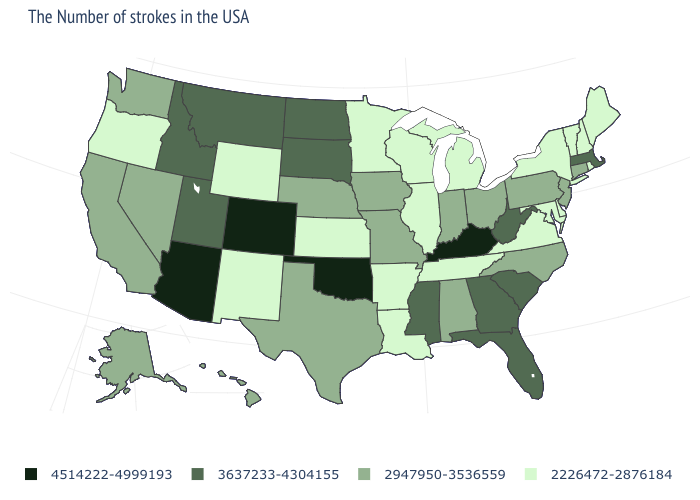What is the value of South Dakota?
Be succinct. 3637233-4304155. What is the value of Nevada?
Answer briefly. 2947950-3536559. Name the states that have a value in the range 2226472-2876184?
Be succinct. Maine, Rhode Island, New Hampshire, Vermont, New York, Delaware, Maryland, Virginia, Michigan, Tennessee, Wisconsin, Illinois, Louisiana, Arkansas, Minnesota, Kansas, Wyoming, New Mexico, Oregon. Is the legend a continuous bar?
Quick response, please. No. What is the value of Missouri?
Give a very brief answer. 2947950-3536559. What is the value of Rhode Island?
Give a very brief answer. 2226472-2876184. Does Oklahoma have the highest value in the USA?
Write a very short answer. Yes. Which states have the lowest value in the USA?
Keep it brief. Maine, Rhode Island, New Hampshire, Vermont, New York, Delaware, Maryland, Virginia, Michigan, Tennessee, Wisconsin, Illinois, Louisiana, Arkansas, Minnesota, Kansas, Wyoming, New Mexico, Oregon. Which states have the lowest value in the USA?
Quick response, please. Maine, Rhode Island, New Hampshire, Vermont, New York, Delaware, Maryland, Virginia, Michigan, Tennessee, Wisconsin, Illinois, Louisiana, Arkansas, Minnesota, Kansas, Wyoming, New Mexico, Oregon. Does Colorado have the highest value in the USA?
Be succinct. Yes. Name the states that have a value in the range 3637233-4304155?
Be succinct. Massachusetts, South Carolina, West Virginia, Florida, Georgia, Mississippi, South Dakota, North Dakota, Utah, Montana, Idaho. Does Nevada have the lowest value in the USA?
Give a very brief answer. No. What is the lowest value in the USA?
Write a very short answer. 2226472-2876184. Name the states that have a value in the range 3637233-4304155?
Write a very short answer. Massachusetts, South Carolina, West Virginia, Florida, Georgia, Mississippi, South Dakota, North Dakota, Utah, Montana, Idaho. Name the states that have a value in the range 2947950-3536559?
Write a very short answer. Connecticut, New Jersey, Pennsylvania, North Carolina, Ohio, Indiana, Alabama, Missouri, Iowa, Nebraska, Texas, Nevada, California, Washington, Alaska, Hawaii. 